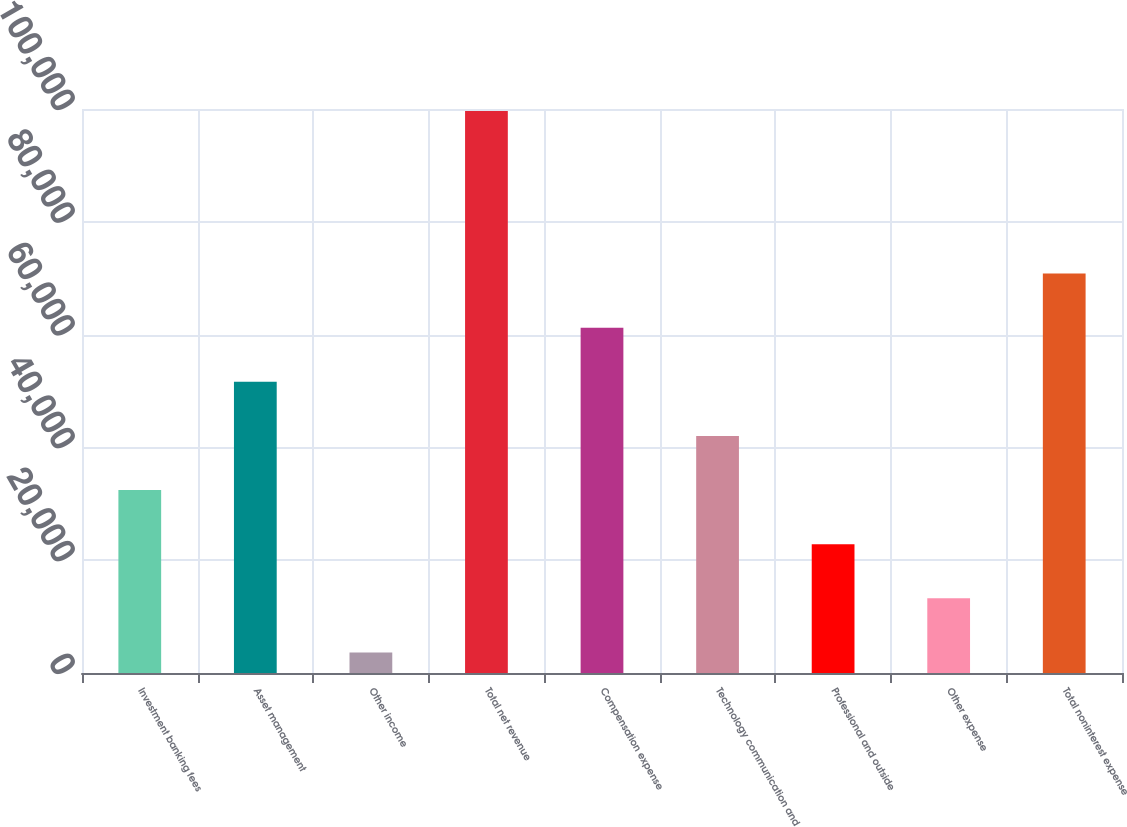Convert chart to OTSL. <chart><loc_0><loc_0><loc_500><loc_500><bar_chart><fcel>Investment banking fees<fcel>Asset management<fcel>Other income<fcel>Total net revenue<fcel>Compensation expense<fcel>Technology communication and<fcel>Professional and outside<fcel>Other expense<fcel>Total noninterest expense<nl><fcel>32434.5<fcel>51631.5<fcel>3639<fcel>99624<fcel>61230<fcel>42033<fcel>22836<fcel>13237.5<fcel>70828.5<nl></chart> 